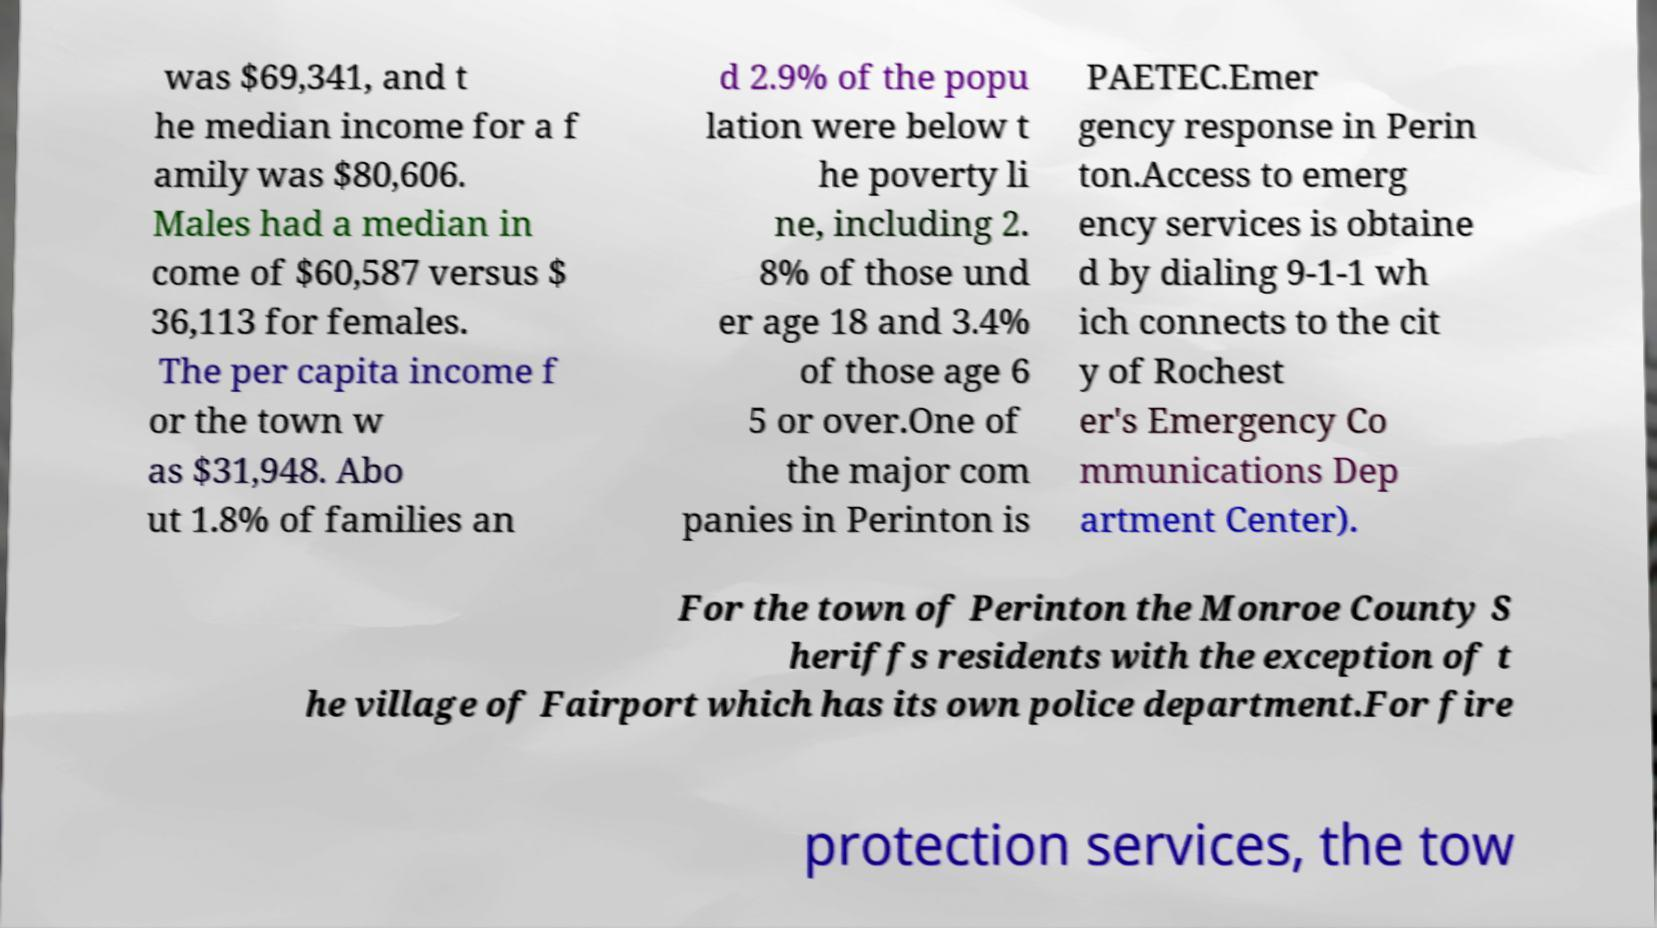Can you accurately transcribe the text from the provided image for me? was $69,341, and t he median income for a f amily was $80,606. Males had a median in come of $60,587 versus $ 36,113 for females. The per capita income f or the town w as $31,948. Abo ut 1.8% of families an d 2.9% of the popu lation were below t he poverty li ne, including 2. 8% of those und er age 18 and 3.4% of those age 6 5 or over.One of the major com panies in Perinton is PAETEC.Emer gency response in Perin ton.Access to emerg ency services is obtaine d by dialing 9-1-1 wh ich connects to the cit y of Rochest er's Emergency Co mmunications Dep artment Center). For the town of Perinton the Monroe County S heriffs residents with the exception of t he village of Fairport which has its own police department.For fire protection services, the tow 